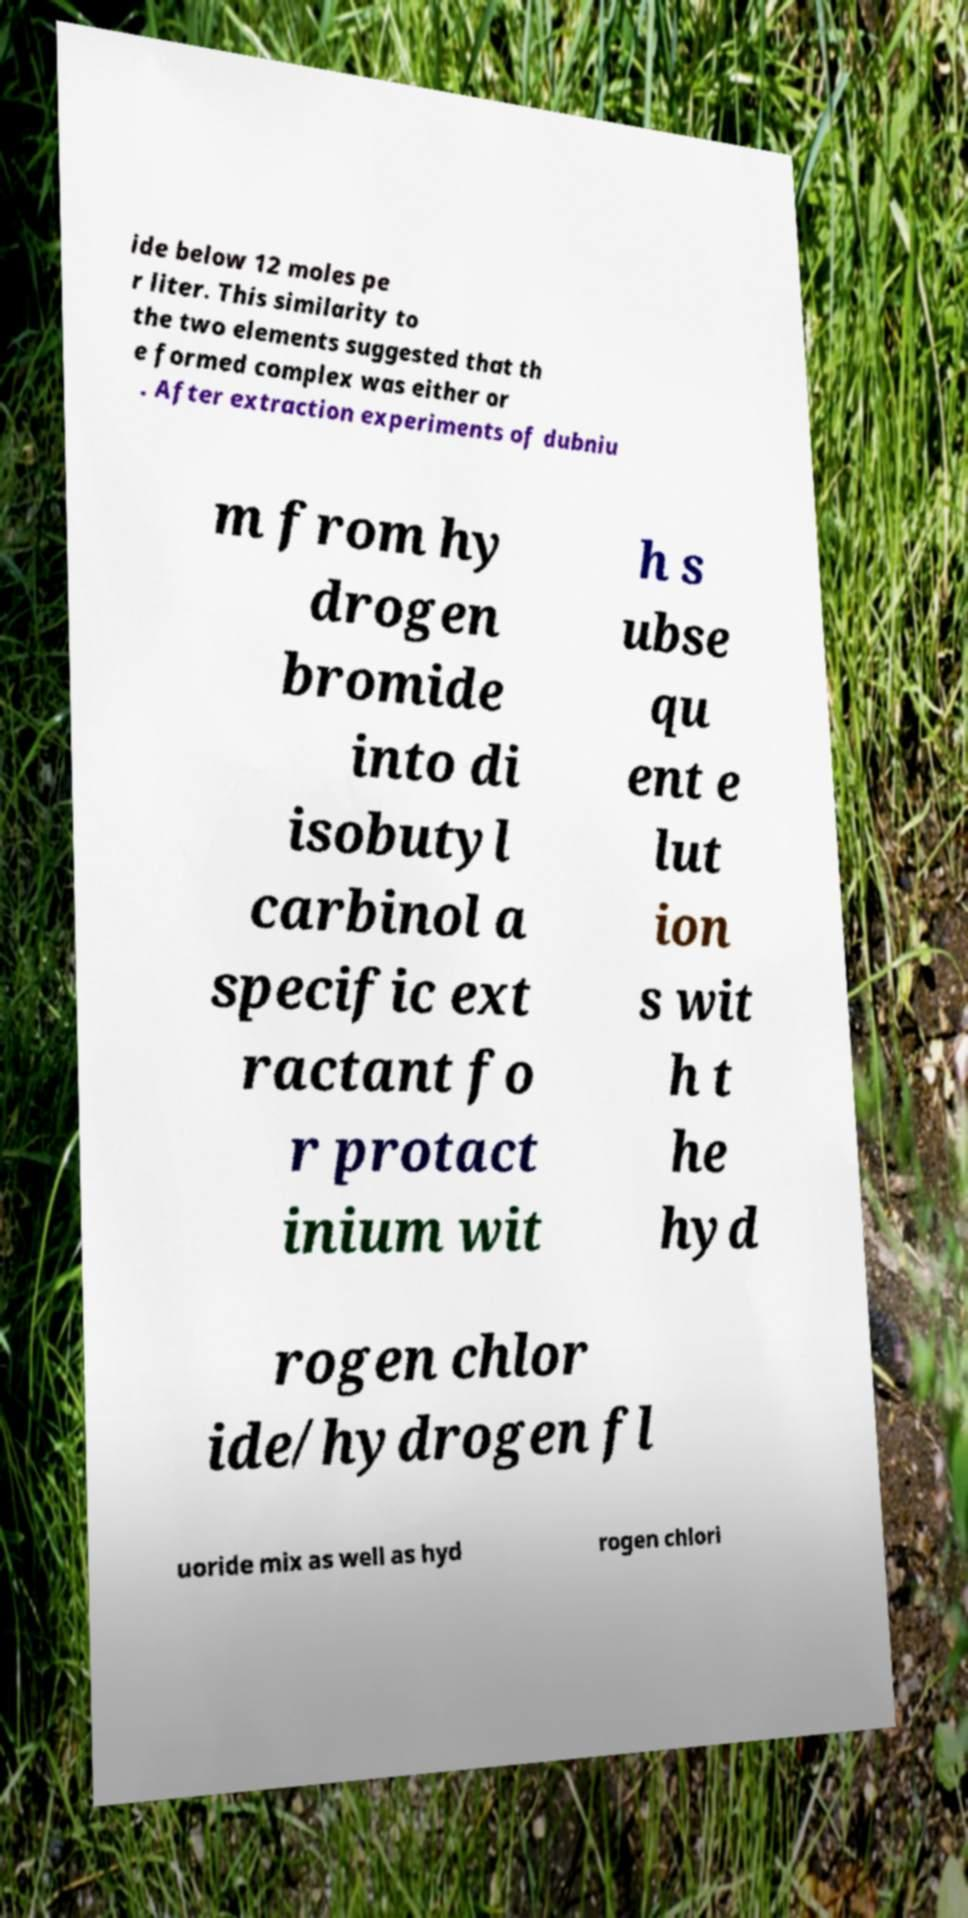Can you accurately transcribe the text from the provided image for me? ide below 12 moles pe r liter. This similarity to the two elements suggested that th e formed complex was either or . After extraction experiments of dubniu m from hy drogen bromide into di isobutyl carbinol a specific ext ractant fo r protact inium wit h s ubse qu ent e lut ion s wit h t he hyd rogen chlor ide/hydrogen fl uoride mix as well as hyd rogen chlori 